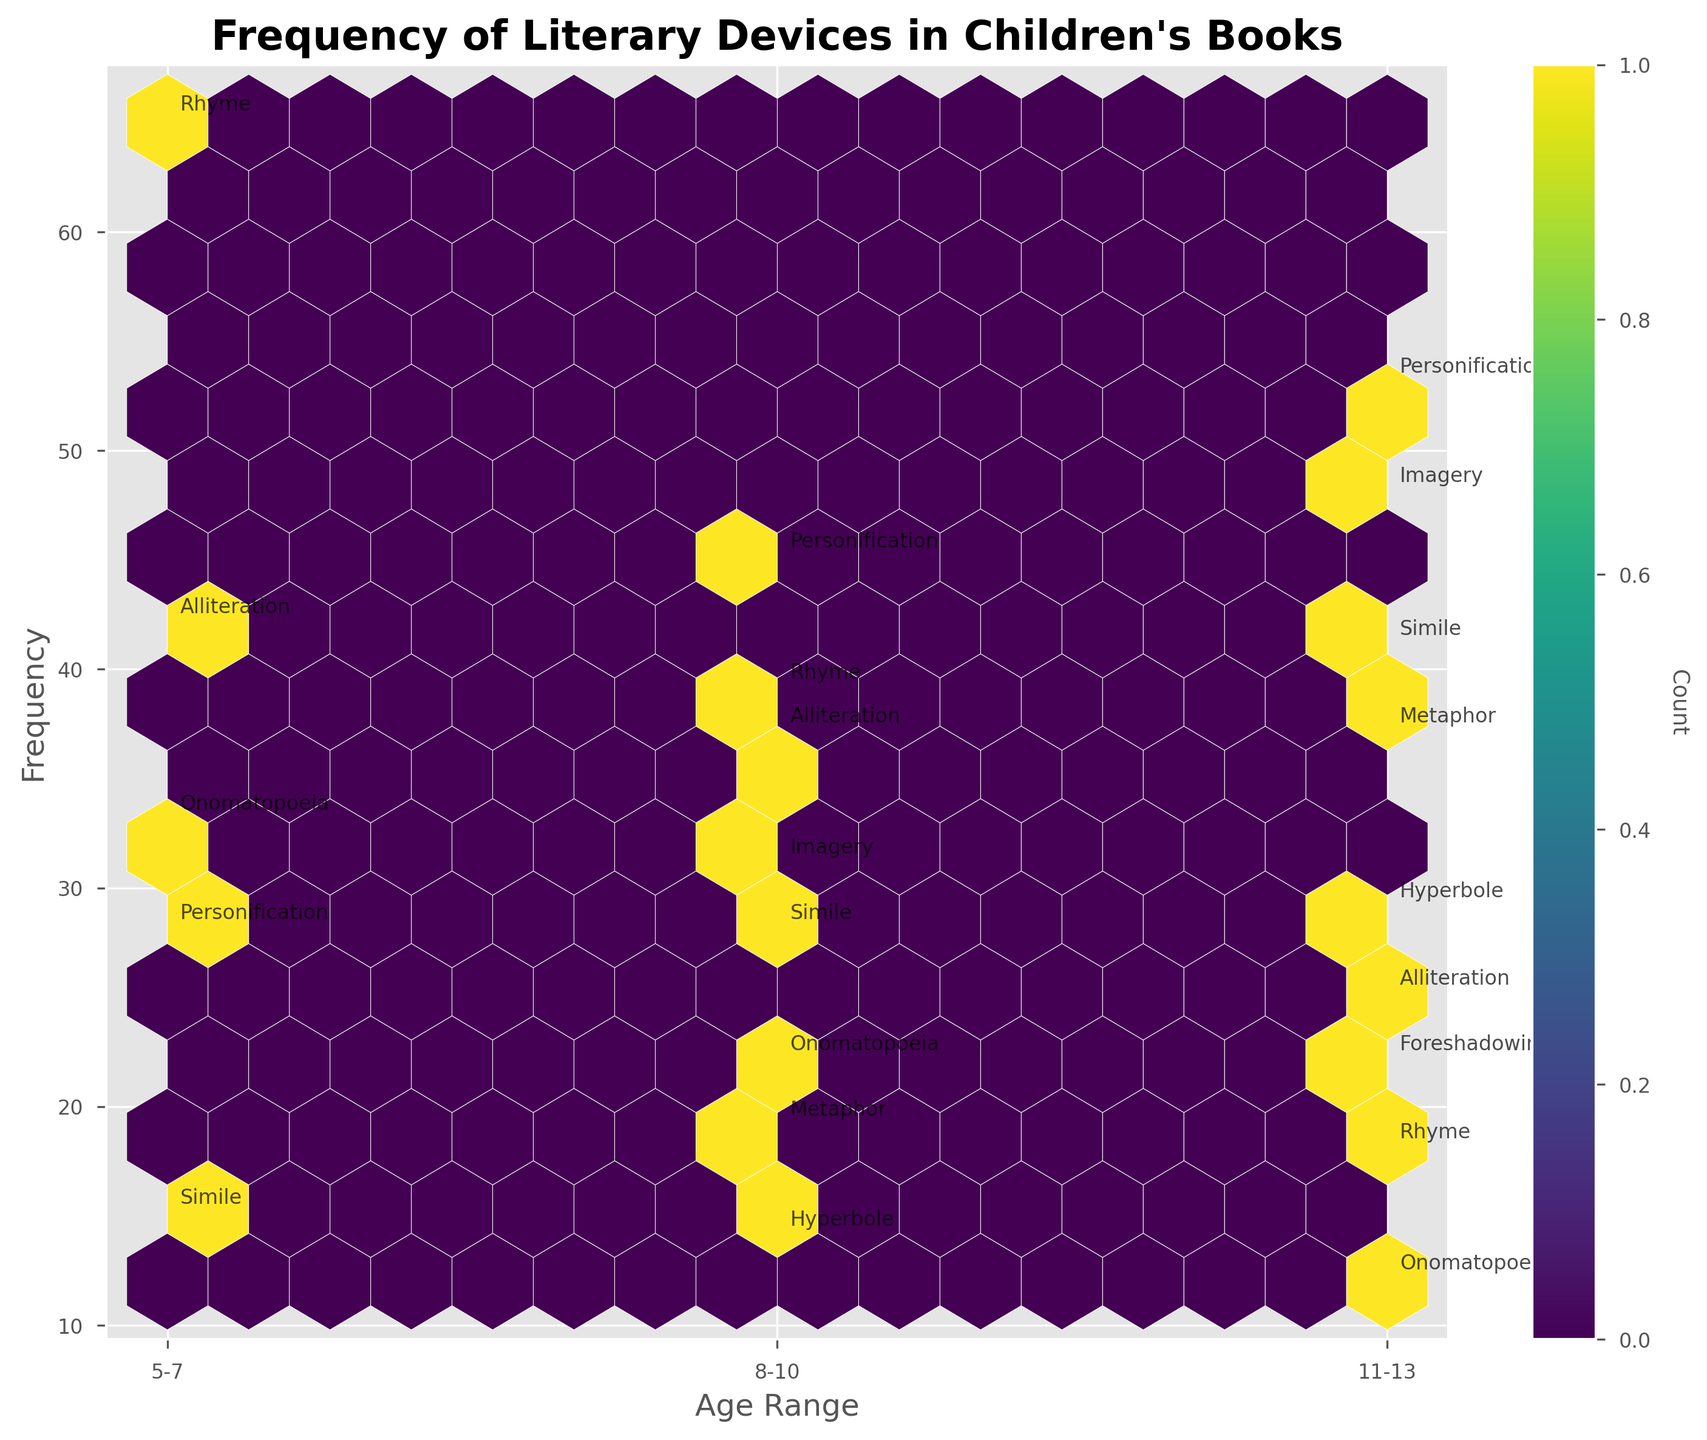What does the title of the plot indicate about the data shown? The title of the plot is "Frequency of Literary Devices in Children's Books". This indicates that the plot shows how often different literary devices are used in popular children's books and categorizes this frequency across different age ranges.
Answer: Frequency of Literary Devices in Children's Books What are the age ranges shown on the x-axis? The x-axis shows the age ranges: "5-7", "8-10", and "11-13". These correspond to different groups of children by age to indicate how the use of literary devices varies across these age groups.
Answer: 5-7, 8-10, 11-13 What color map is used in the hexbin plot, and what does it represent? The color map used in the hexbin plot is "viridis". It represents the density of the points, with different colors showing how many data points fall within each hexagonal bin.
Answer: viridis Which age range has the highest density of literary device usage? By observing the color gradient in the hexbin plot, the age range "5-7" has the highest density of literary device usage, indicated by the darker color in that section.
Answer: 5-7 How does the frequency of "Alliteration" change across the age ranges? To find this out, look at the annotated positions for "Alliteration" across each age range. The frequency decreases as follows: 42 for age range 5-7, 37 for age range 8-10, and 25 for age range 11-13.
Answer: It decreases Which literary device has the highest frequency in the age range 8-10? Among the annotations for the age range 8-10, "Personification" has a frequency of 45, and thus it is the highest.
Answer: Personification What is the total frequency of "Onomatopoeia" across all age ranges? Sum up the frequencies of "Onomatopoeia" across age ranges: 33 (5-7) + 22 (8-10) + 12 (11-13) to get the total frequency.
Answer: 67 Compare the frequency of "Simile" and "Imagery" in the age range 11-13. Which one is used more frequently? By looking at the annotated positions, "Simile" has a frequency of 41 and "Imagery" has a frequency of 48 in the age range 11-13. Therefore, "Imagery" is used more frequently.
Answer: Imagery Which literary device appears exclusively in the age ranges 8-10 and 11-13 but not in 5-7? By checking the annotations, "Metaphor", "Hyperbole", "Imagery", and "Foreshadowing" appear in age ranges 8-10 and 11-13 but are not present in age range 5-7.
Answer: Metaphor, Hyperbole, Imagery, Foreshadowing How many literary device entries are there for the age range 11-13? Count all the annotated entries under age range 11-13. These are "Alliteration", "Personification", "Rhyme", "Simile", "Onomatopoeia", "Metaphor", "Hyperbole", "Imagery", and "Foreshadowing", totaling 9 entries.
Answer: 9 